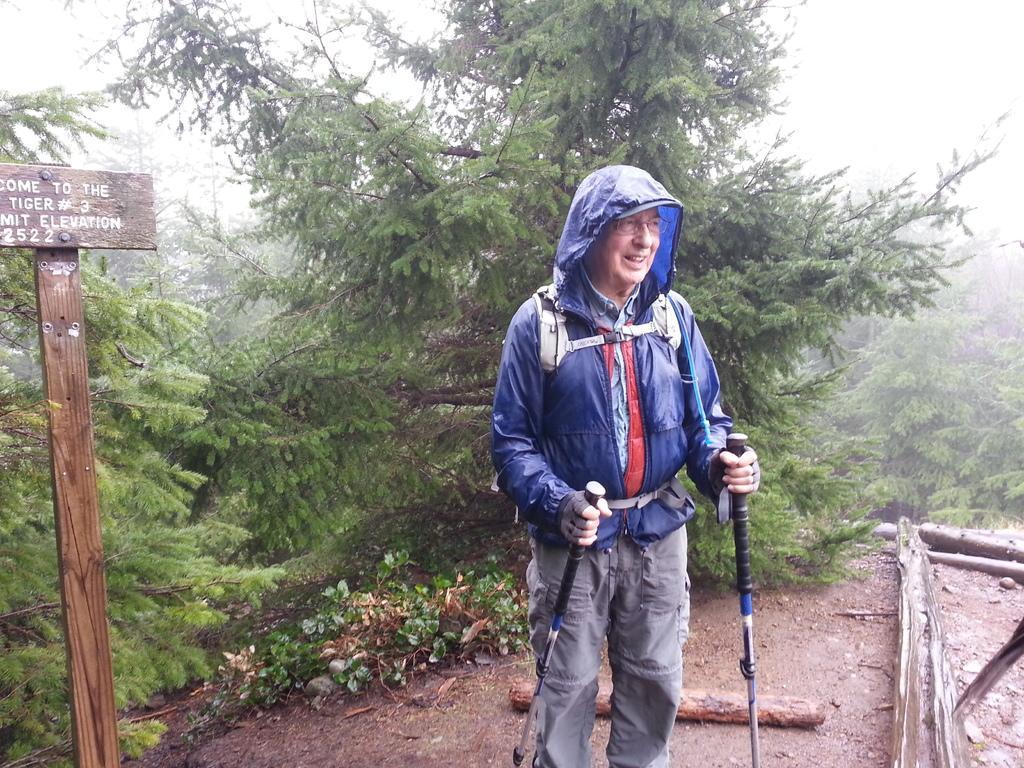In one or two sentences, can you explain what this image depicts? In this image there is a men wearing blue color raincoat, grey color pant, holding sticks in his hands giving a pose to a photograph, in the background there are plants and to a side there are logs. 